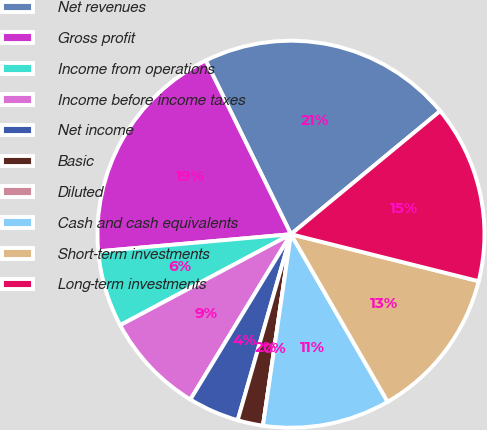Convert chart. <chart><loc_0><loc_0><loc_500><loc_500><pie_chart><fcel>Net revenues<fcel>Gross profit<fcel>Income from operations<fcel>Income before income taxes<fcel>Net income<fcel>Basic<fcel>Diluted<fcel>Cash and cash equivalents<fcel>Short-term investments<fcel>Long-term investments<nl><fcel>21.28%<fcel>19.15%<fcel>6.38%<fcel>8.51%<fcel>4.26%<fcel>2.13%<fcel>0.0%<fcel>10.64%<fcel>12.77%<fcel>14.89%<nl></chart> 